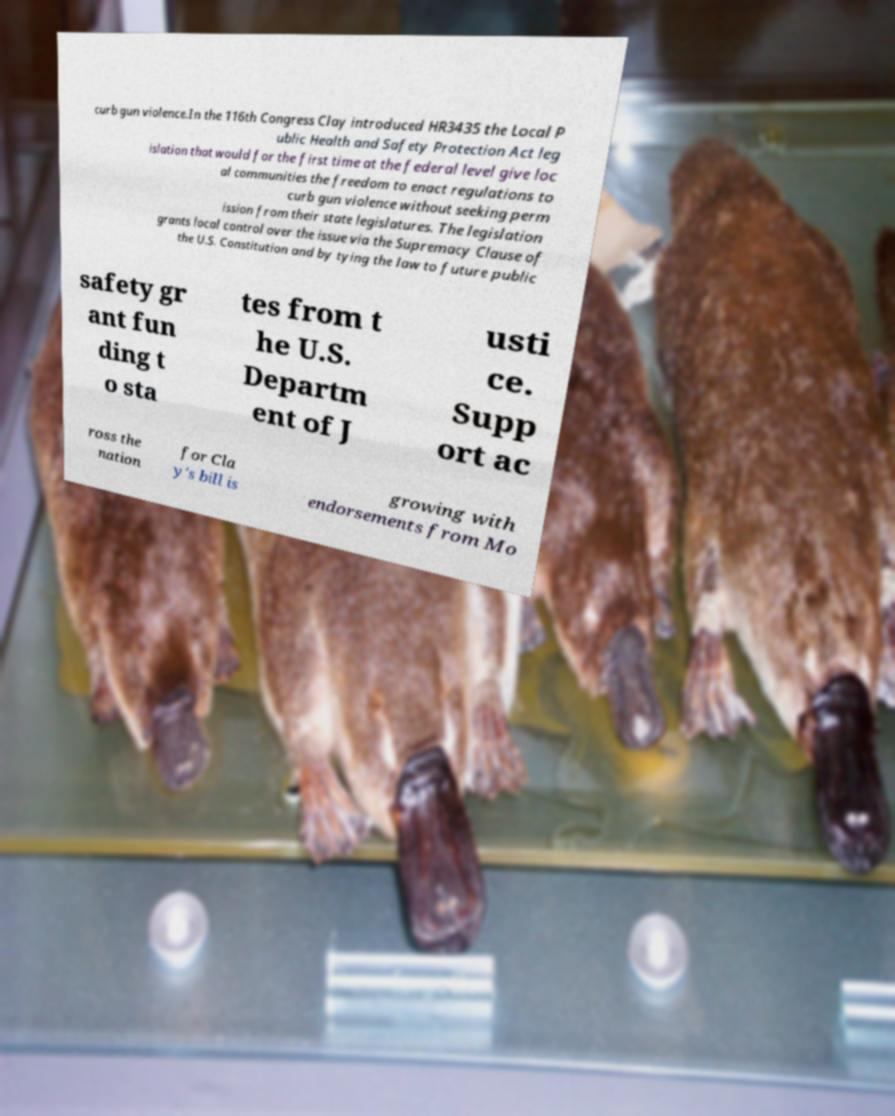For documentation purposes, I need the text within this image transcribed. Could you provide that? curb gun violence.In the 116th Congress Clay introduced HR3435 the Local P ublic Health and Safety Protection Act leg islation that would for the first time at the federal level give loc al communities the freedom to enact regulations to curb gun violence without seeking perm ission from their state legislatures. The legislation grants local control over the issue via the Supremacy Clause of the U.S. Constitution and by tying the law to future public safety gr ant fun ding t o sta tes from t he U.S. Departm ent of J usti ce. Supp ort ac ross the nation for Cla y's bill is growing with endorsements from Mo 